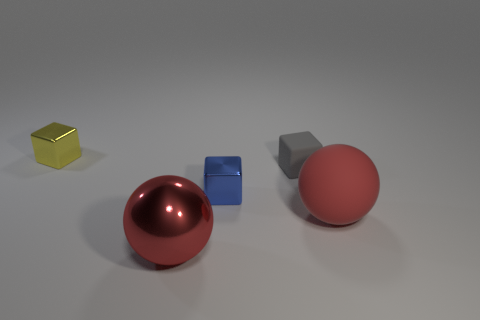There is a block that is in front of the tiny yellow block and to the left of the matte block; what is its size?
Give a very brief answer. Small. How many other things are made of the same material as the tiny gray thing?
Ensure brevity in your answer.  1. What is the size of the yellow metallic block behind the big red shiny sphere?
Ensure brevity in your answer.  Small. Do the large rubber thing and the metal ball have the same color?
Your answer should be compact. Yes. What number of tiny objects are either green cubes or red rubber balls?
Your answer should be compact. 0. Is there anything else that has the same color as the big matte thing?
Give a very brief answer. Yes. Are there any blocks to the left of the small gray rubber thing?
Give a very brief answer. Yes. There is a red object that is in front of the sphere that is right of the blue object; what size is it?
Provide a short and direct response. Large. Are there the same number of tiny gray rubber objects that are in front of the small rubber block and large things that are behind the yellow thing?
Your answer should be compact. Yes. Are there any cubes that are left of the metal block that is in front of the tiny yellow metal cube?
Provide a succinct answer. Yes. 